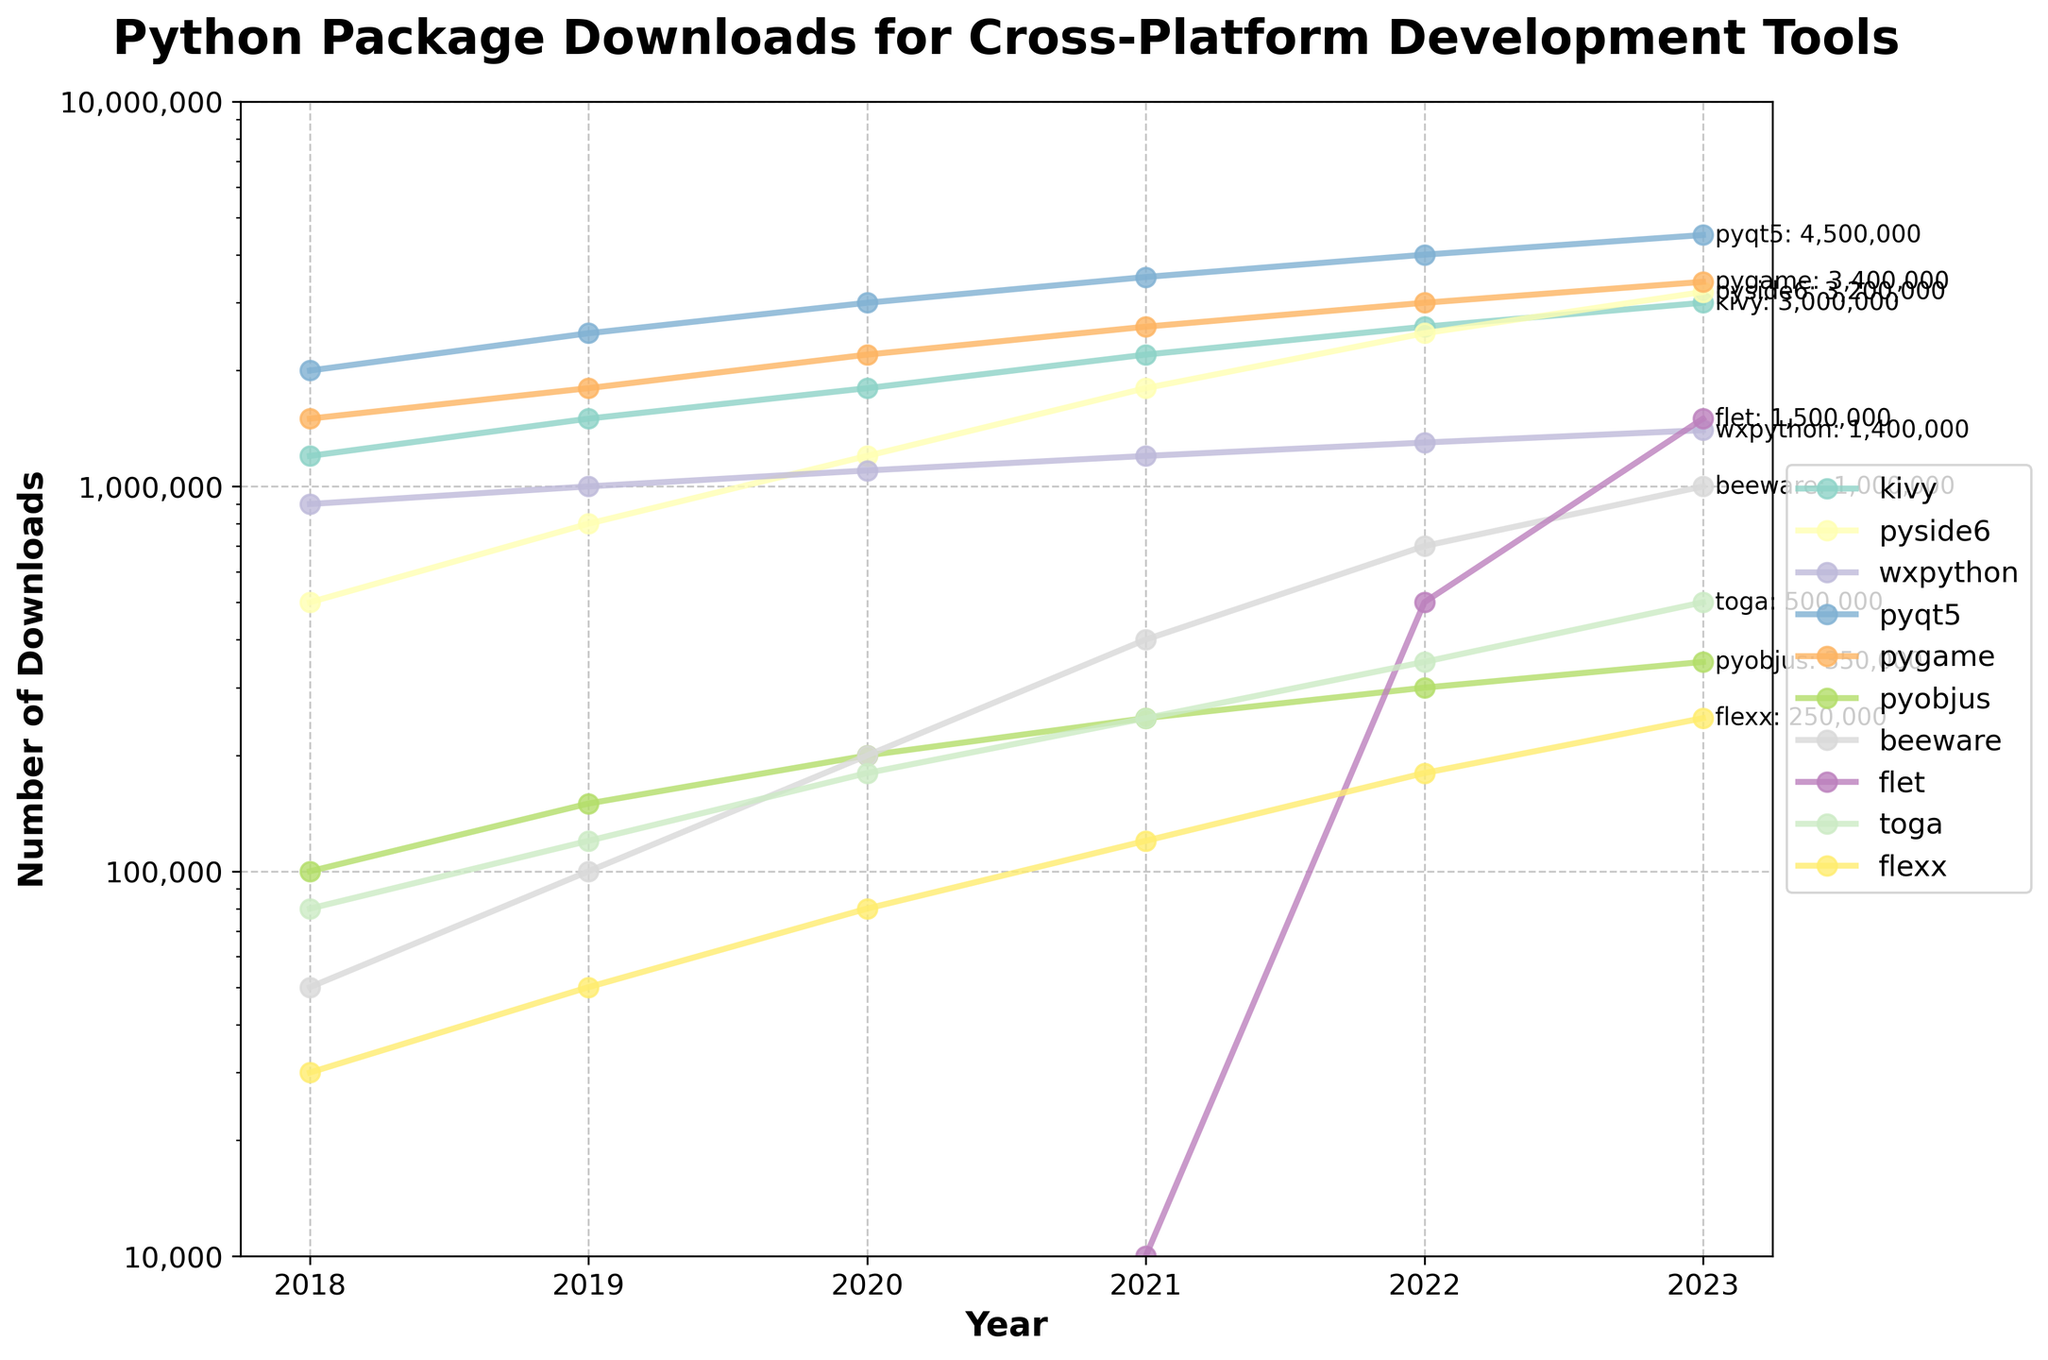Which package had the highest number of downloads in 2023? Identify the highest point on the y-axis for the year 2023 and check the corresponding label in the legend. The highest number of downloads registered is for PyQT5.
Answer: PyQT5 Which package showed the most significant growth in downloads from 2022 to 2023? Calculate the difference in the number of downloads between 2022 and 2023 for each package and compare the values. PySide6 grew from 2,500,000 to 3,200,000, which is the largest increase of 700,000.
Answer: PySide6 What is the total number of downloads for Toga from 2018 to 2023? Add the number of downloads for Toga for each year from 2018 to 2023: 80,000 + 120,000 + 180,000 + 250,000 + 350,000 + 500,000 = 1,480,000.
Answer: 1,480,000 Which package had fewer than 500,000 downloads every year? Look at the lines and labels; find the packages that never reach past the 500,000 mark on the y-axis. Pyobjus, Beeware, Toga, and Flexx fit this criterion.
Answer: Pyobjus, Beeware, Toga, Flexx By how much did Kivy’s downloads increase from 2018 to 2023? Subtract Kivy's downloads in 2018 from its downloads in 2023: 3,000,000 - 1,200,000 = 1,800,000.
Answer: 1,800,000 Which package had the second-highest downloads in 2022? Identify the second-highest value on the y-axis for 2022, using the legend for reference. The second-highest downloads in 2022 were for PyGame.
Answer: PyGame Is the trend of Flet's downloads an exponential growth from 2018 to 2023? Examine the steepness and direction of Flet's line on the chart from 2018 to 2023, demonstrating significant growth after 2020. Its growth is very sharp, indicating exponential growth.
Answer: Yes Which two packages' download numbers were close to each other in 2023? Compare the values in 2023; Kivy and PyGame show downloads close to each other with 3,000,000 and 3,400,000 downloads, respectively.
Answer: Kivy and PyGame 